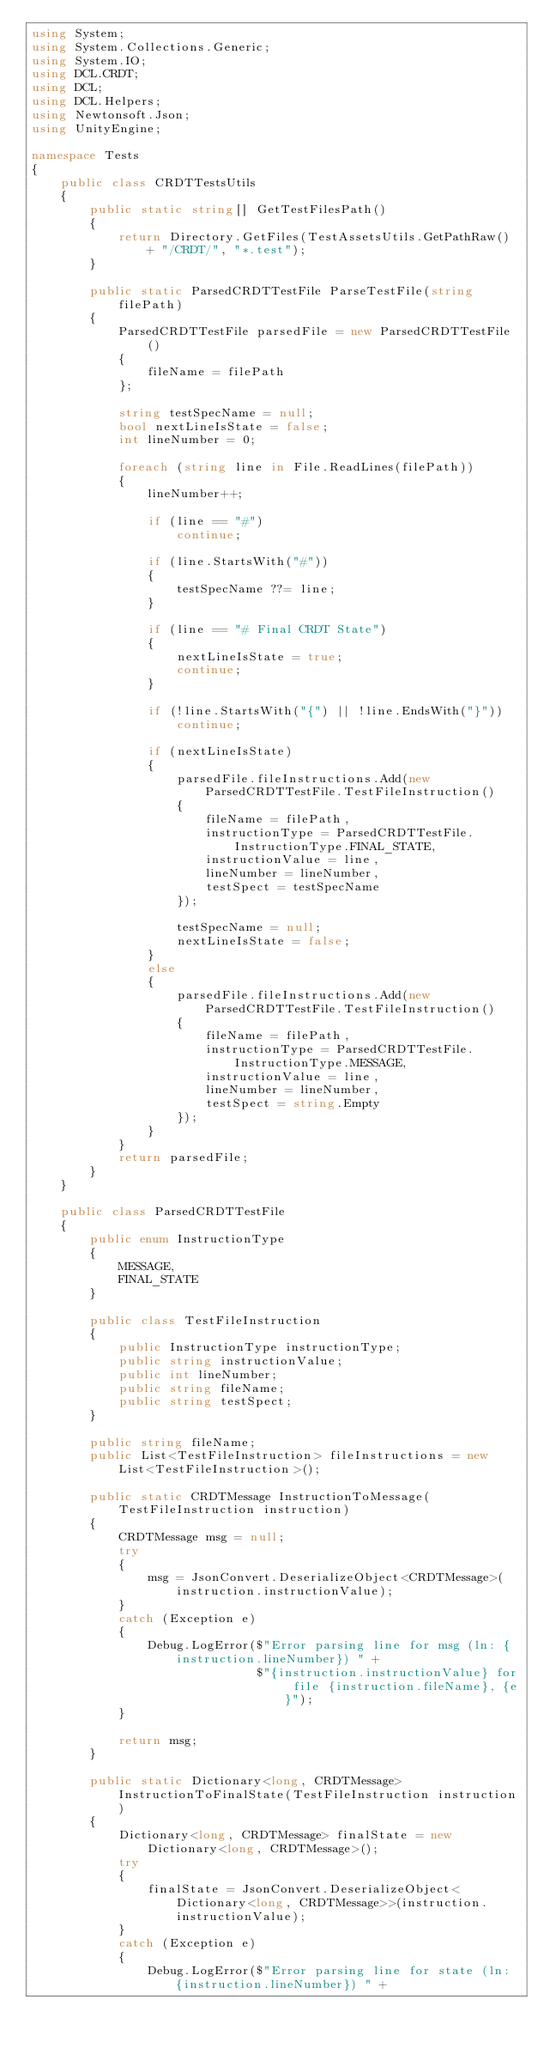<code> <loc_0><loc_0><loc_500><loc_500><_C#_>using System;
using System.Collections.Generic;
using System.IO;
using DCL.CRDT;
using DCL;
using DCL.Helpers;
using Newtonsoft.Json;
using UnityEngine;

namespace Tests
{
    public class CRDTTestsUtils
    {
        public static string[] GetTestFilesPath()
        {
            return Directory.GetFiles(TestAssetsUtils.GetPathRaw() + "/CRDT/", "*.test");
        }

        public static ParsedCRDTTestFile ParseTestFile(string filePath)
        {
            ParsedCRDTTestFile parsedFile = new ParsedCRDTTestFile()
            {
                fileName = filePath
            };

            string testSpecName = null;
            bool nextLineIsState = false;
            int lineNumber = 0;

            foreach (string line in File.ReadLines(filePath))
            {
                lineNumber++;

                if (line == "#")
                    continue;

                if (line.StartsWith("#"))
                {
                    testSpecName ??= line;
                }

                if (line == "# Final CRDT State")
                {
                    nextLineIsState = true;
                    continue;
                }

                if (!line.StartsWith("{") || !line.EndsWith("}"))
                    continue;

                if (nextLineIsState)
                {
                    parsedFile.fileInstructions.Add(new ParsedCRDTTestFile.TestFileInstruction()
                    {
                        fileName = filePath,
                        instructionType = ParsedCRDTTestFile.InstructionType.FINAL_STATE,
                        instructionValue = line,
                        lineNumber = lineNumber,
                        testSpect = testSpecName
                    });

                    testSpecName = null;
                    nextLineIsState = false;
                }
                else
                {
                    parsedFile.fileInstructions.Add(new ParsedCRDTTestFile.TestFileInstruction()
                    {
                        fileName = filePath,
                        instructionType = ParsedCRDTTestFile.InstructionType.MESSAGE,
                        instructionValue = line,
                        lineNumber = lineNumber,
                        testSpect = string.Empty
                    });
                }
            }
            return parsedFile;
        }
    }

    public class ParsedCRDTTestFile
    {
        public enum InstructionType
        {
            MESSAGE,
            FINAL_STATE
        }

        public class TestFileInstruction
        {
            public InstructionType instructionType;
            public string instructionValue;
            public int lineNumber;
            public string fileName;
            public string testSpect;
        }

        public string fileName;
        public List<TestFileInstruction> fileInstructions = new List<TestFileInstruction>();

        public static CRDTMessage InstructionToMessage(TestFileInstruction instruction)
        {
            CRDTMessage msg = null;
            try
            {
                msg = JsonConvert.DeserializeObject<CRDTMessage>(instruction.instructionValue);
            }
            catch (Exception e)
            {
                Debug.LogError($"Error parsing line for msg (ln: {instruction.lineNumber}) " +
                               $"{instruction.instructionValue} for file {instruction.fileName}, {e}");
            }

            return msg;
        }

        public static Dictionary<long, CRDTMessage> InstructionToFinalState(TestFileInstruction instruction)
        {
            Dictionary<long, CRDTMessage> finalState = new Dictionary<long, CRDTMessage>();
            try
            {
                finalState = JsonConvert.DeserializeObject<Dictionary<long, CRDTMessage>>(instruction.instructionValue);
            }
            catch (Exception e)
            {
                Debug.LogError($"Error parsing line for state (ln: {instruction.lineNumber}) " +</code> 